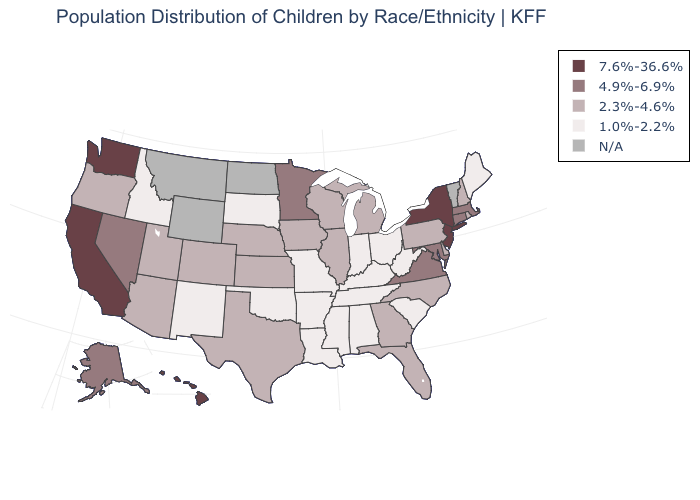Name the states that have a value in the range 2.3%-4.6%?
Quick response, please. Arizona, Colorado, Delaware, Florida, Georgia, Illinois, Iowa, Kansas, Michigan, Nebraska, New Hampshire, North Carolina, Oregon, Pennsylvania, Rhode Island, Texas, Utah, Wisconsin. What is the value of Wyoming?
Concise answer only. N/A. Name the states that have a value in the range 4.9%-6.9%?
Give a very brief answer. Alaska, Connecticut, Maryland, Massachusetts, Minnesota, Nevada, Virginia. Does the map have missing data?
Concise answer only. Yes. Does Maine have the lowest value in the Northeast?
Be succinct. Yes. What is the value of Nevada?
Give a very brief answer. 4.9%-6.9%. Name the states that have a value in the range 2.3%-4.6%?
Quick response, please. Arizona, Colorado, Delaware, Florida, Georgia, Illinois, Iowa, Kansas, Michigan, Nebraska, New Hampshire, North Carolina, Oregon, Pennsylvania, Rhode Island, Texas, Utah, Wisconsin. What is the highest value in states that border Idaho?
Write a very short answer. 7.6%-36.6%. What is the lowest value in states that border Iowa?
Be succinct. 1.0%-2.2%. Name the states that have a value in the range 7.6%-36.6%?
Write a very short answer. California, Hawaii, New Jersey, New York, Washington. What is the lowest value in the MidWest?
Short answer required. 1.0%-2.2%. What is the highest value in the MidWest ?
Quick response, please. 4.9%-6.9%. 